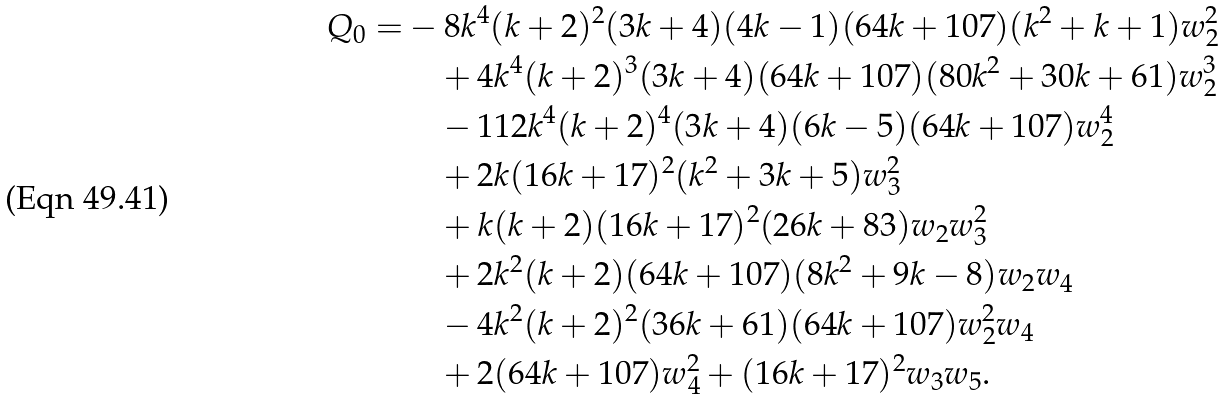Convert formula to latex. <formula><loc_0><loc_0><loc_500><loc_500>Q _ { 0 } = & - 8 k ^ { 4 } ( k + 2 ) ^ { 2 } ( 3 k + 4 ) ( 4 k - 1 ) ( 6 4 k + 1 0 7 ) ( k ^ { 2 } + k + 1 ) w _ { 2 } ^ { 2 } \\ & \quad + 4 k ^ { 4 } ( k + 2 ) ^ { 3 } ( 3 k + 4 ) ( 6 4 k + 1 0 7 ) ( 8 0 k ^ { 2 } + 3 0 k + 6 1 ) w _ { 2 } ^ { 3 } \\ & \quad - 1 1 2 k ^ { 4 } ( k + 2 ) ^ { 4 } ( 3 k + 4 ) ( 6 k - 5 ) ( 6 4 k + 1 0 7 ) w _ { 2 } ^ { 4 } \\ & \quad + 2 k ( 1 6 k + 1 7 ) ^ { 2 } ( k ^ { 2 } + 3 k + 5 ) w _ { 3 } ^ { 2 } \\ & \quad + k ( k + 2 ) ( 1 6 k + 1 7 ) ^ { 2 } ( 2 6 k + 8 3 ) w _ { 2 } w _ { 3 } ^ { 2 } \\ & \quad + 2 k ^ { 2 } ( k + 2 ) ( 6 4 k + 1 0 7 ) ( 8 k ^ { 2 } + 9 k - 8 ) w _ { 2 } w _ { 4 } \\ & \quad - 4 k ^ { 2 } ( k + 2 ) ^ { 2 } ( 3 6 k + 6 1 ) ( 6 4 k + 1 0 7 ) w _ { 2 } ^ { 2 } w _ { 4 } \\ & \quad + 2 ( 6 4 k + 1 0 7 ) w _ { 4 } ^ { 2 } + ( 1 6 k + 1 7 ) ^ { 2 } w _ { 3 } w _ { 5 } .</formula> 